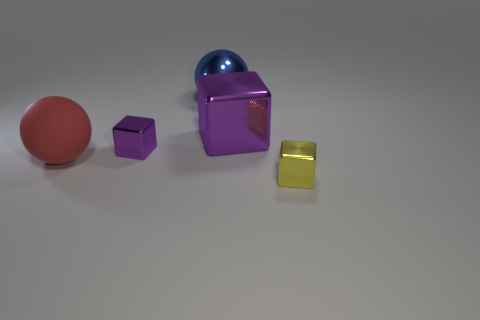Subtract all big purple metal blocks. How many blocks are left? 2 Subtract all yellow blocks. How many blocks are left? 2 Add 5 large purple things. How many objects exist? 10 Subtract all cubes. How many objects are left? 2 Subtract all cyan spheres. How many purple cubes are left? 2 Subtract 0 blue cubes. How many objects are left? 5 Subtract 3 cubes. How many cubes are left? 0 Subtract all blue spheres. Subtract all brown blocks. How many spheres are left? 1 Subtract all blue objects. Subtract all gray cubes. How many objects are left? 4 Add 2 small yellow cubes. How many small yellow cubes are left? 3 